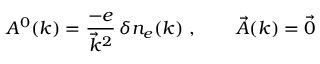Convert formula to latex. <formula><loc_0><loc_0><loc_500><loc_500>A ^ { 0 } ( k ) = \frac { - e } { \vec { k } ^ { 2 } } \, \delta n _ { e } ( k ) \ , \quad \vec { A } ( k ) = \vec { 0 }</formula> 